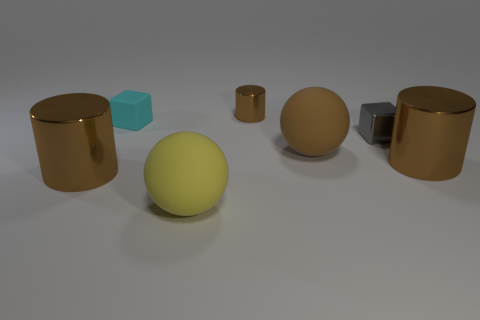There is a shiny thing that is both to the left of the metal cube and in front of the shiny block; how big is it?
Your response must be concise. Large. What number of other objects are the same color as the shiny cube?
Make the answer very short. 0. What size is the brown metallic object on the right side of the large ball that is behind the big brown thing that is on the left side of the cyan block?
Ensure brevity in your answer.  Large. Are there any tiny things on the right side of the small brown metal thing?
Ensure brevity in your answer.  Yes. There is a gray metallic cube; does it have the same size as the brown rubber ball in front of the cyan thing?
Offer a very short reply. No. How many other things are there of the same material as the yellow thing?
Offer a very short reply. 2. There is a brown metallic thing that is both right of the cyan matte block and in front of the tiny matte thing; what shape is it?
Provide a short and direct response. Cylinder. Does the matte sphere behind the big yellow rubber object have the same size as the cylinder to the left of the yellow matte sphere?
Make the answer very short. Yes. The big object that is the same material as the big yellow sphere is what shape?
Your answer should be compact. Sphere. Is there anything else that has the same shape as the large yellow object?
Your answer should be very brief. Yes. 